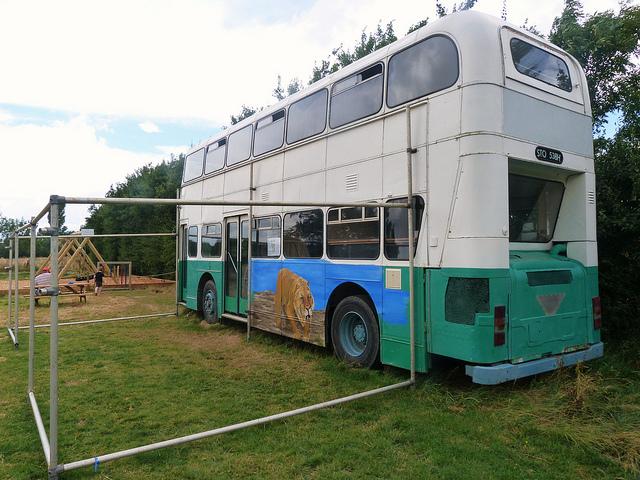Is this a mobile home?
Give a very brief answer. No. What animal is painted on the bus?
Concise answer only. Lion. What kind of vehicle is this?
Keep it brief. Bus. 